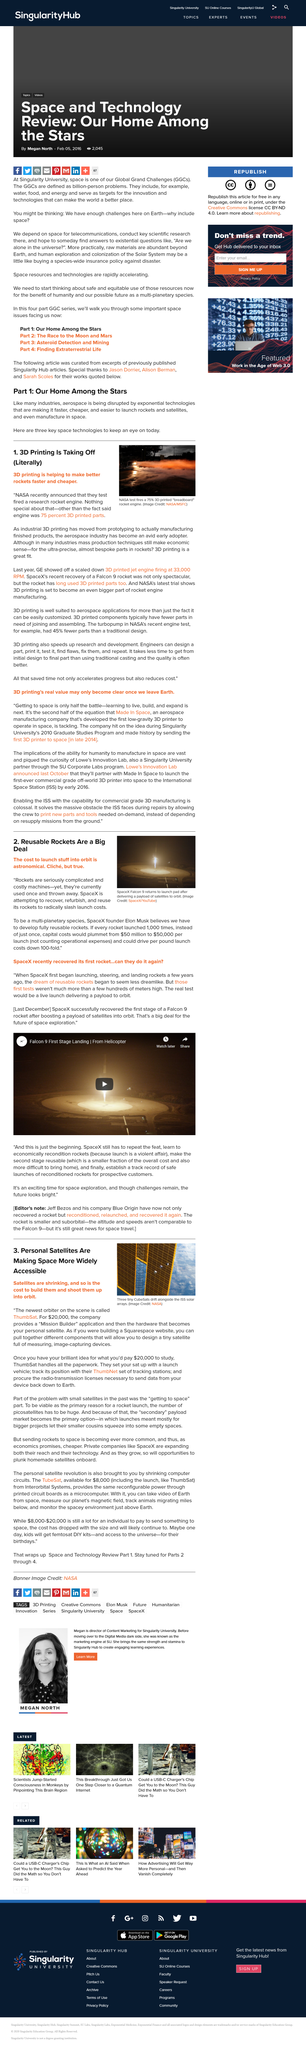Indicate a few pertinent items in this graphic. The estimated capital cost per launch would be significantly reduced if reusable rockets are utilized, potentially reaching as low as $50,000 per launch. SpaceX recently recovered a Falcon 9 rocket. ThumbNet is the company responsible for enabling users to construct their own satellites for personal use. SpaceX is developing reusable rockets as part of its efforts to advance the field of rocket technology. The past problem with small satellite launches was that they were not viable due to the high cost and challenges associated with getting to space. 